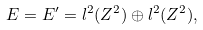Convert formula to latex. <formula><loc_0><loc_0><loc_500><loc_500>E = E ^ { \prime } = { l ^ { 2 } } ( { Z } ^ { 2 } ) \oplus { l ^ { 2 } } ( { Z } ^ { 2 } ) ,</formula> 